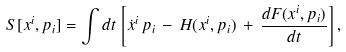Convert formula to latex. <formula><loc_0><loc_0><loc_500><loc_500>S [ x ^ { i } , p _ { i } ] = \int d t \, \left [ \dot { x } ^ { i } \, p _ { i } \, - \, H ( x ^ { i } , p _ { i } ) \, + \, \frac { d F ( x ^ { i } , p _ { i } ) } { d t } \right ] ,</formula> 